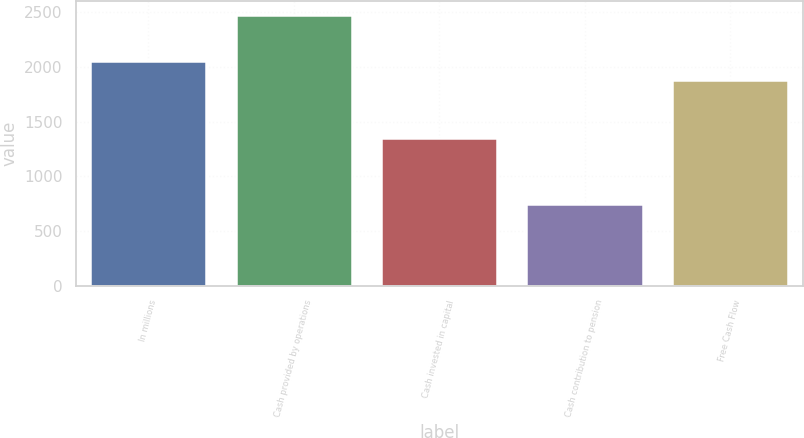Convert chart to OTSL. <chart><loc_0><loc_0><loc_500><loc_500><bar_chart><fcel>In millions<fcel>Cash provided by operations<fcel>Cash invested in capital<fcel>Cash contribution to pension<fcel>Free Cash Flow<nl><fcel>2052.8<fcel>2478<fcel>1348<fcel>750<fcel>1880<nl></chart> 